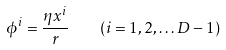<formula> <loc_0><loc_0><loc_500><loc_500>\phi ^ { i } = \frac { \eta x ^ { i } } { r } \quad ( i = 1 , 2 , \dots D - 1 )</formula> 